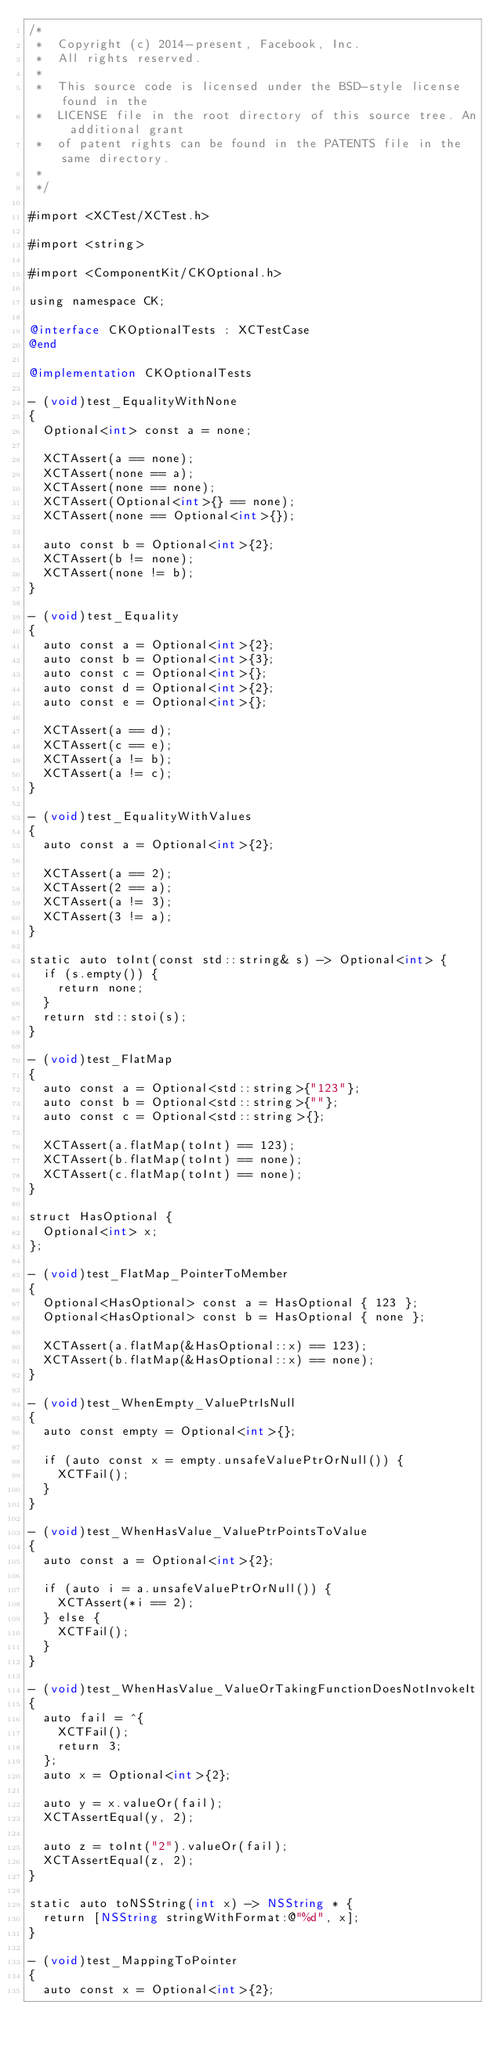Convert code to text. <code><loc_0><loc_0><loc_500><loc_500><_ObjectiveC_>/*
 *  Copyright (c) 2014-present, Facebook, Inc.
 *  All rights reserved.
 *
 *  This source code is licensed under the BSD-style license found in the
 *  LICENSE file in the root directory of this source tree. An additional grant
 *  of patent rights can be found in the PATENTS file in the same directory.
 *
 */

#import <XCTest/XCTest.h>

#import <string>

#import <ComponentKit/CKOptional.h>

using namespace CK;

@interface CKOptionalTests : XCTestCase
@end

@implementation CKOptionalTests

- (void)test_EqualityWithNone
{
  Optional<int> const a = none;

  XCTAssert(a == none);
  XCTAssert(none == a);
  XCTAssert(none == none);
  XCTAssert(Optional<int>{} == none);
  XCTAssert(none == Optional<int>{});

  auto const b = Optional<int>{2};
  XCTAssert(b != none);
  XCTAssert(none != b);
}

- (void)test_Equality
{
  auto const a = Optional<int>{2};
  auto const b = Optional<int>{3};
  auto const c = Optional<int>{};
  auto const d = Optional<int>{2};
  auto const e = Optional<int>{};

  XCTAssert(a == d);
  XCTAssert(c == e);
  XCTAssert(a != b);
  XCTAssert(a != c);
}

- (void)test_EqualityWithValues
{
  auto const a = Optional<int>{2};

  XCTAssert(a == 2);
  XCTAssert(2 == a);
  XCTAssert(a != 3);
  XCTAssert(3 != a);
}

static auto toInt(const std::string& s) -> Optional<int> {
  if (s.empty()) {
    return none;
  }
  return std::stoi(s);
}

- (void)test_FlatMap
{
  auto const a = Optional<std::string>{"123"};
  auto const b = Optional<std::string>{""};
  auto const c = Optional<std::string>{};

  XCTAssert(a.flatMap(toInt) == 123);
  XCTAssert(b.flatMap(toInt) == none);
  XCTAssert(c.flatMap(toInt) == none);
}

struct HasOptional {
  Optional<int> x;
};

- (void)test_FlatMap_PointerToMember
{
  Optional<HasOptional> const a = HasOptional { 123 };
  Optional<HasOptional> const b = HasOptional { none };

  XCTAssert(a.flatMap(&HasOptional::x) == 123);
  XCTAssert(b.flatMap(&HasOptional::x) == none);
}

- (void)test_WhenEmpty_ValuePtrIsNull
{
  auto const empty = Optional<int>{};

  if (auto const x = empty.unsafeValuePtrOrNull()) {
    XCTFail();
  }
}

- (void)test_WhenHasValue_ValuePtrPointsToValue
{
  auto const a = Optional<int>{2};

  if (auto i = a.unsafeValuePtrOrNull()) {
    XCTAssert(*i == 2);
  } else {
    XCTFail();
  }
}

- (void)test_WhenHasValue_ValueOrTakingFunctionDoesNotInvokeIt
{
  auto fail = ^{
    XCTFail();
    return 3;
  };
  auto x = Optional<int>{2};

  auto y = x.valueOr(fail);
  XCTAssertEqual(y, 2);

  auto z = toInt("2").valueOr(fail);
  XCTAssertEqual(z, 2);
}

static auto toNSString(int x) -> NSString * {
  return [NSString stringWithFormat:@"%d", x];
}

- (void)test_MappingToPointer
{
  auto const x = Optional<int>{2};
</code> 